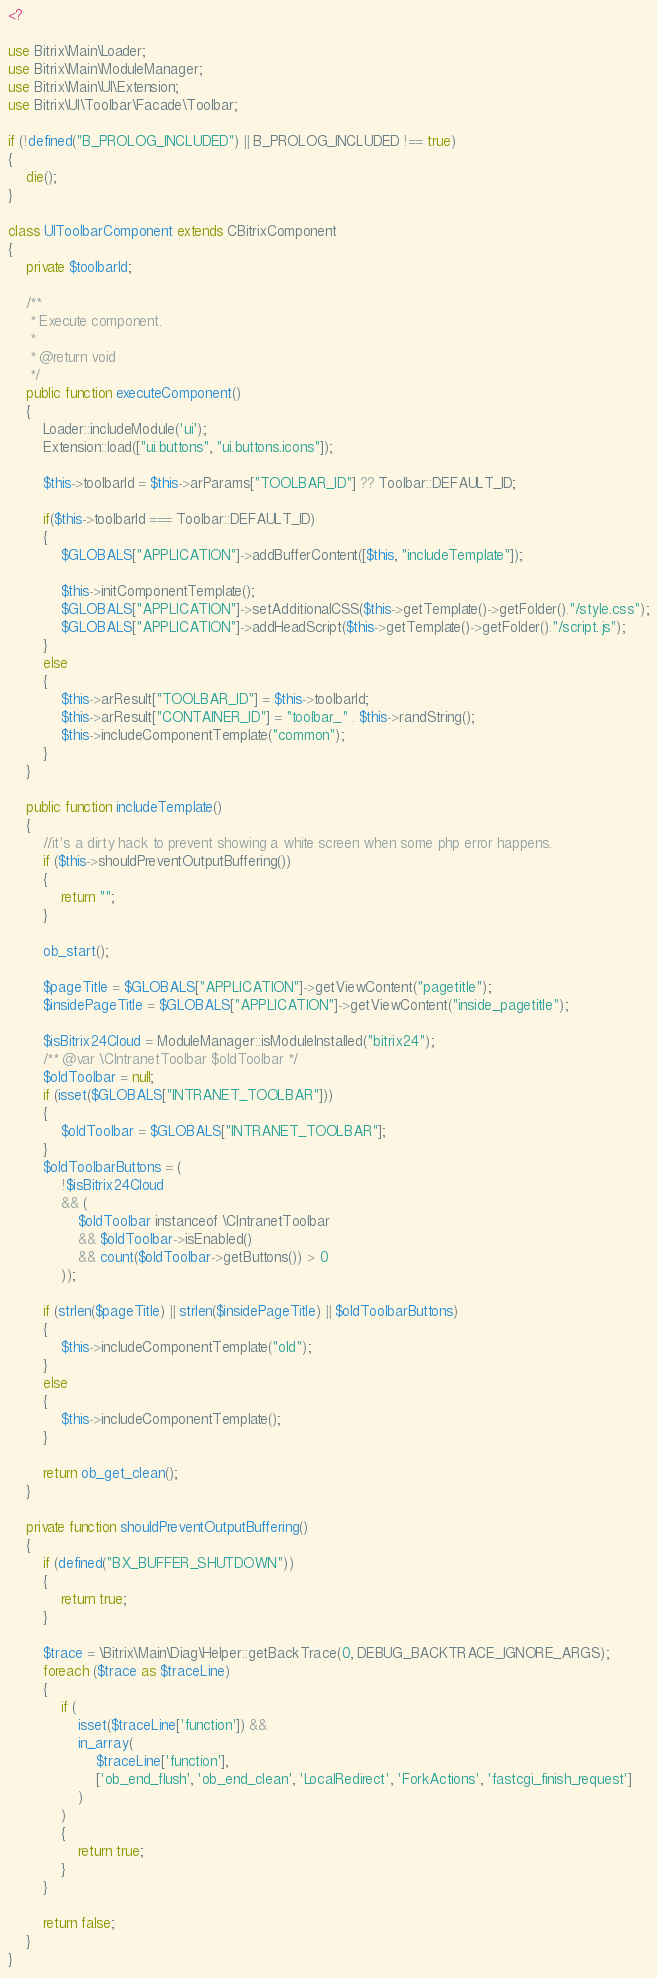<code> <loc_0><loc_0><loc_500><loc_500><_PHP_><?

use Bitrix\Main\Loader;
use Bitrix\Main\ModuleManager;
use Bitrix\Main\UI\Extension;
use Bitrix\UI\Toolbar\Facade\Toolbar;

if (!defined("B_PROLOG_INCLUDED") || B_PROLOG_INCLUDED !== true)
{
	die();
}

class UIToolbarComponent extends CBitrixComponent
{
	private $toolbarId;

	/**
	 * Execute component.
	 *
	 * @return void
	 */
	public function executeComponent()
	{
		Loader::includeModule('ui');
		Extension::load(["ui.buttons", "ui.buttons.icons"]);

		$this->toolbarId = $this->arParams["TOOLBAR_ID"] ?? Toolbar::DEFAULT_ID;

		if($this->toolbarId === Toolbar::DEFAULT_ID)
		{
			$GLOBALS["APPLICATION"]->addBufferContent([$this, "includeTemplate"]);

			$this->initComponentTemplate();
			$GLOBALS["APPLICATION"]->setAdditionalCSS($this->getTemplate()->getFolder()."/style.css");
			$GLOBALS["APPLICATION"]->addHeadScript($this->getTemplate()->getFolder()."/script.js");
		}
		else
		{
			$this->arResult["TOOLBAR_ID"] = $this->toolbarId;
			$this->arResult["CONTAINER_ID"] = "toolbar_" . $this->randString();
			$this->includeComponentTemplate("common");
		}
	}

	public function includeTemplate()
	{
		//it's a dirty hack to prevent showing a white screen when some php error happens.
		if ($this->shouldPreventOutputBuffering())
		{
			return "";
		}

		ob_start();

		$pageTitle = $GLOBALS["APPLICATION"]->getViewContent("pagetitle");
		$insidePageTitle = $GLOBALS["APPLICATION"]->getViewContent("inside_pagetitle");

		$isBitrix24Cloud = ModuleManager::isModuleInstalled("bitrix24");
		/** @var \CIntranetToolbar $oldToolbar */
		$oldToolbar = null;
		if (isset($GLOBALS["INTRANET_TOOLBAR"]))
		{
			$oldToolbar = $GLOBALS["INTRANET_TOOLBAR"];
		}
		$oldToolbarButtons = (
			!$isBitrix24Cloud
			&& (
				$oldToolbar instanceof \CIntranetToolbar
				&& $oldToolbar->isEnabled()
				&& count($oldToolbar->getButtons()) > 0
			));

		if (strlen($pageTitle) || strlen($insidePageTitle) || $oldToolbarButtons)
		{
			$this->includeComponentTemplate("old");
		}
		else
		{
			$this->includeComponentTemplate();
		}

		return ob_get_clean();
	}

	private function shouldPreventOutputBuffering()
	{
		if (defined("BX_BUFFER_SHUTDOWN"))
		{
			return true;
		}

		$trace = \Bitrix\Main\Diag\Helper::getBackTrace(0, DEBUG_BACKTRACE_IGNORE_ARGS);
		foreach ($trace as $traceLine)
		{
			if (
				isset($traceLine['function']) &&
				in_array(
					$traceLine['function'],
					['ob_end_flush', 'ob_end_clean', 'LocalRedirect', 'ForkActions', 'fastcgi_finish_request']
				)
			)
			{
				return true;
			}
		}

		return false;
	}
}</code> 